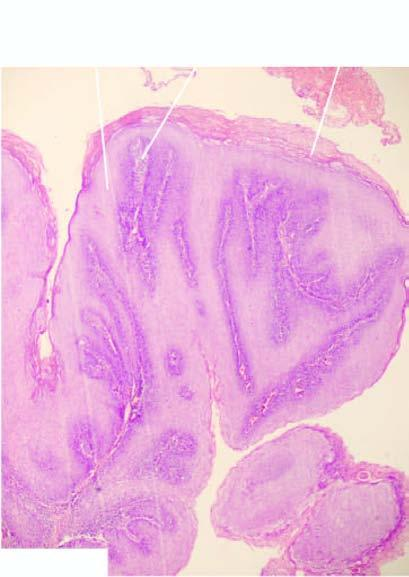s the alveolar septa papillomatosis?
Answer the question using a single word or phrase. No 